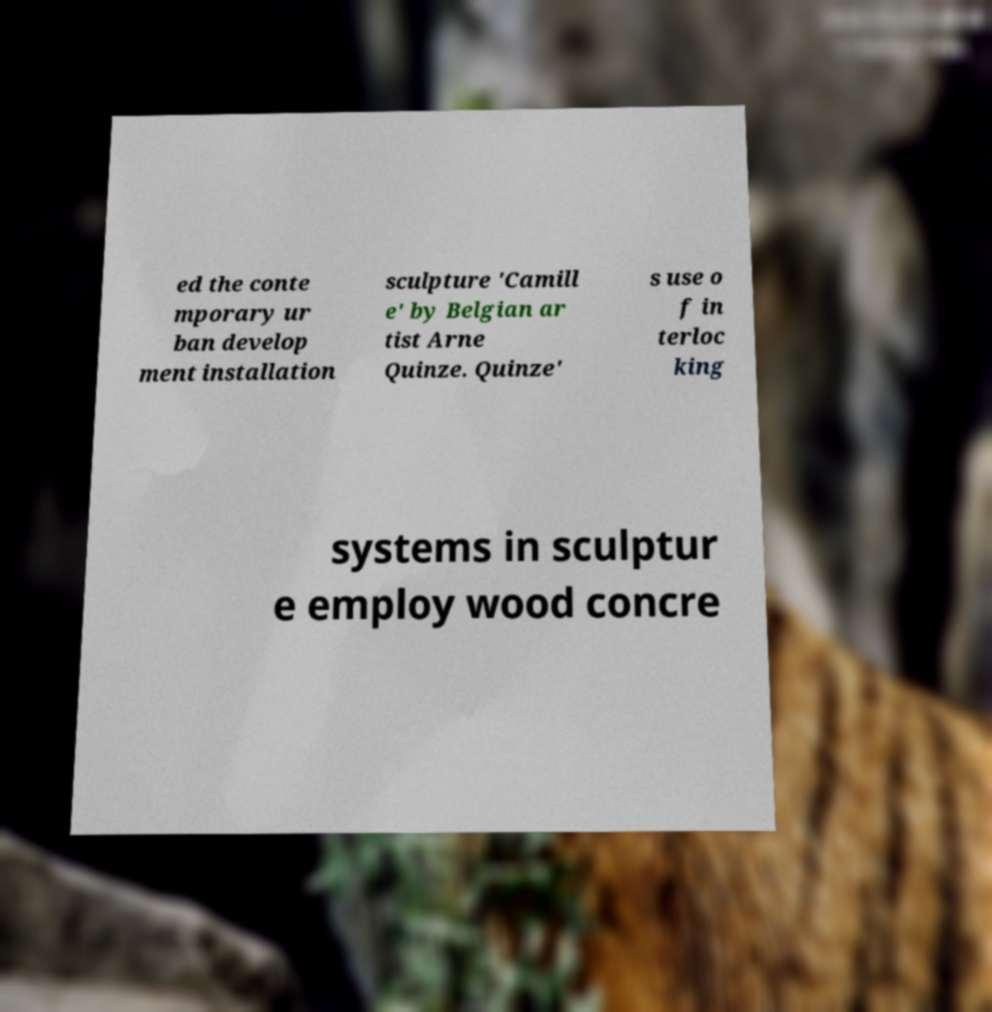Please read and relay the text visible in this image. What does it say? ed the conte mporary ur ban develop ment installation sculpture 'Camill e' by Belgian ar tist Arne Quinze. Quinze' s use o f in terloc king systems in sculptur e employ wood concre 